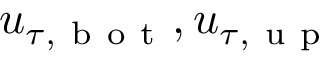Convert formula to latex. <formula><loc_0><loc_0><loc_500><loc_500>u _ { \tau , b o t } , u _ { \tau , u p }</formula> 